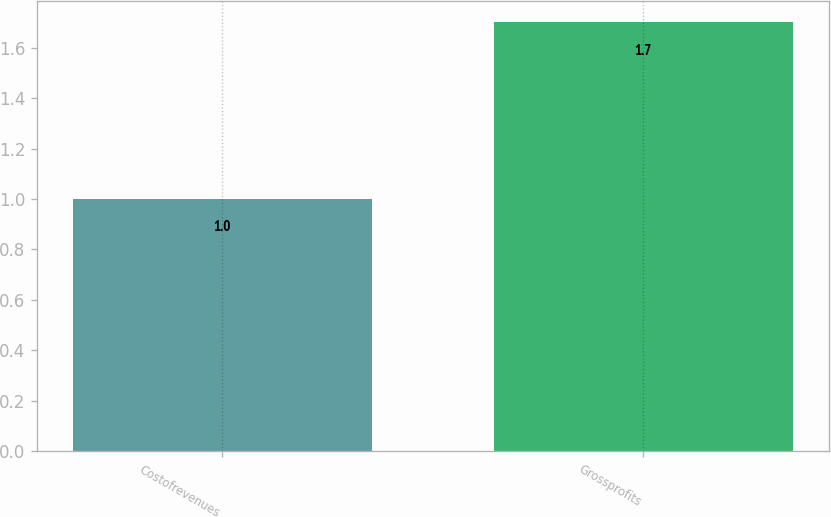<chart> <loc_0><loc_0><loc_500><loc_500><bar_chart><fcel>Costofrevenues<fcel>Grossprofits<nl><fcel>1<fcel>1.7<nl></chart> 